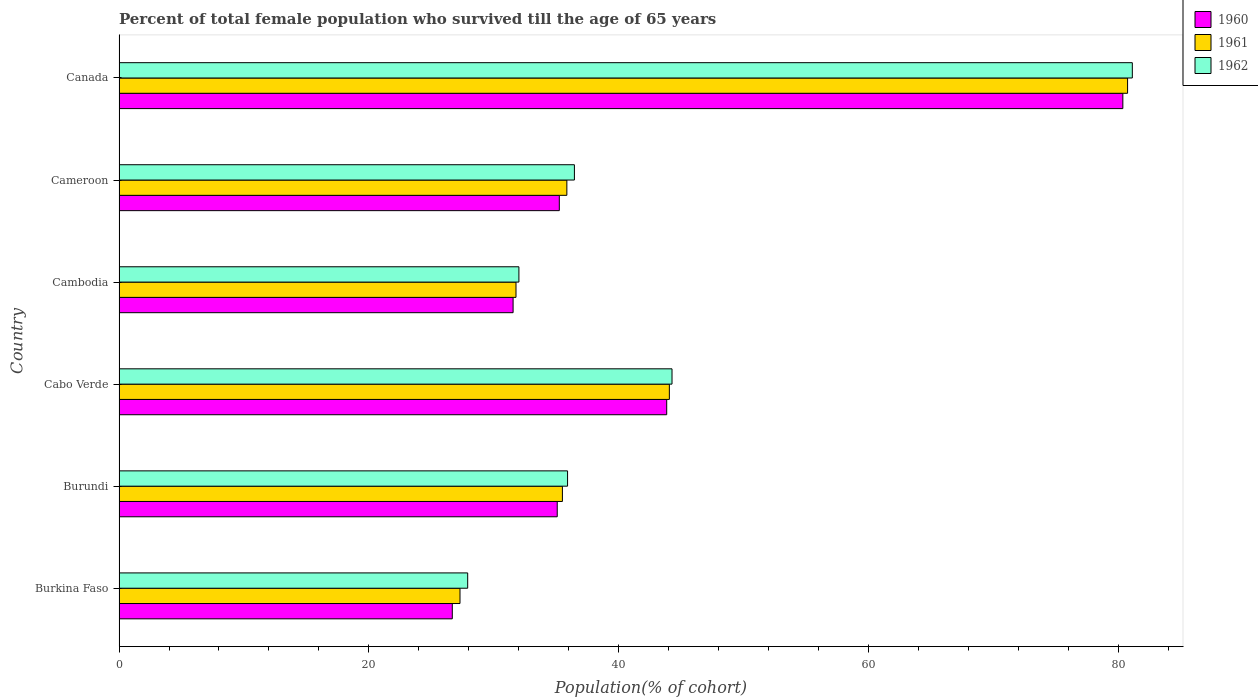How many different coloured bars are there?
Ensure brevity in your answer.  3. How many groups of bars are there?
Your answer should be very brief. 6. Are the number of bars on each tick of the Y-axis equal?
Provide a succinct answer. Yes. What is the label of the 4th group of bars from the top?
Ensure brevity in your answer.  Cabo Verde. What is the percentage of total female population who survived till the age of 65 years in 1960 in Canada?
Give a very brief answer. 80.38. Across all countries, what is the maximum percentage of total female population who survived till the age of 65 years in 1960?
Offer a very short reply. 80.38. Across all countries, what is the minimum percentage of total female population who survived till the age of 65 years in 1961?
Keep it short and to the point. 27.3. In which country was the percentage of total female population who survived till the age of 65 years in 1960 minimum?
Provide a succinct answer. Burkina Faso. What is the total percentage of total female population who survived till the age of 65 years in 1960 in the graph?
Your answer should be compact. 252.8. What is the difference between the percentage of total female population who survived till the age of 65 years in 1962 in Burkina Faso and that in Burundi?
Offer a terse response. -8. What is the difference between the percentage of total female population who survived till the age of 65 years in 1960 in Burkina Faso and the percentage of total female population who survived till the age of 65 years in 1961 in Canada?
Your answer should be very brief. -54.07. What is the average percentage of total female population who survived till the age of 65 years in 1960 per country?
Your answer should be very brief. 42.13. What is the difference between the percentage of total female population who survived till the age of 65 years in 1960 and percentage of total female population who survived till the age of 65 years in 1962 in Burkina Faso?
Provide a short and direct response. -1.23. In how many countries, is the percentage of total female population who survived till the age of 65 years in 1962 greater than 40 %?
Your answer should be compact. 2. What is the ratio of the percentage of total female population who survived till the age of 65 years in 1960 in Burundi to that in Cambodia?
Offer a very short reply. 1.11. What is the difference between the highest and the second highest percentage of total female population who survived till the age of 65 years in 1961?
Provide a succinct answer. 36.69. What is the difference between the highest and the lowest percentage of total female population who survived till the age of 65 years in 1961?
Offer a very short reply. 53.46. In how many countries, is the percentage of total female population who survived till the age of 65 years in 1961 greater than the average percentage of total female population who survived till the age of 65 years in 1961 taken over all countries?
Ensure brevity in your answer.  2. What does the 2nd bar from the top in Cambodia represents?
Provide a succinct answer. 1961. How many bars are there?
Your answer should be compact. 18. What is the difference between two consecutive major ticks on the X-axis?
Your answer should be very brief. 20. Are the values on the major ticks of X-axis written in scientific E-notation?
Keep it short and to the point. No. Does the graph contain any zero values?
Make the answer very short. No. Does the graph contain grids?
Your response must be concise. No. Where does the legend appear in the graph?
Your answer should be very brief. Top right. How many legend labels are there?
Give a very brief answer. 3. How are the legend labels stacked?
Your answer should be very brief. Vertical. What is the title of the graph?
Your answer should be very brief. Percent of total female population who survived till the age of 65 years. Does "2011" appear as one of the legend labels in the graph?
Give a very brief answer. No. What is the label or title of the X-axis?
Your response must be concise. Population(% of cohort). What is the Population(% of cohort) of 1960 in Burkina Faso?
Give a very brief answer. 26.68. What is the Population(% of cohort) of 1961 in Burkina Faso?
Your answer should be very brief. 27.3. What is the Population(% of cohort) of 1962 in Burkina Faso?
Offer a terse response. 27.92. What is the Population(% of cohort) of 1960 in Burundi?
Ensure brevity in your answer.  35.09. What is the Population(% of cohort) of 1961 in Burundi?
Offer a terse response. 35.5. What is the Population(% of cohort) of 1962 in Burundi?
Give a very brief answer. 35.91. What is the Population(% of cohort) in 1960 in Cabo Verde?
Provide a succinct answer. 43.85. What is the Population(% of cohort) of 1961 in Cabo Verde?
Make the answer very short. 44.06. What is the Population(% of cohort) of 1962 in Cabo Verde?
Your answer should be very brief. 44.28. What is the Population(% of cohort) in 1960 in Cambodia?
Your response must be concise. 31.55. What is the Population(% of cohort) in 1961 in Cambodia?
Provide a succinct answer. 31.78. What is the Population(% of cohort) of 1962 in Cambodia?
Your answer should be compact. 32.02. What is the Population(% of cohort) in 1960 in Cameroon?
Provide a succinct answer. 35.25. What is the Population(% of cohort) of 1961 in Cameroon?
Provide a short and direct response. 35.86. What is the Population(% of cohort) of 1962 in Cameroon?
Ensure brevity in your answer.  36.46. What is the Population(% of cohort) in 1960 in Canada?
Give a very brief answer. 80.38. What is the Population(% of cohort) of 1961 in Canada?
Your answer should be compact. 80.76. What is the Population(% of cohort) of 1962 in Canada?
Provide a succinct answer. 81.14. Across all countries, what is the maximum Population(% of cohort) in 1960?
Your response must be concise. 80.38. Across all countries, what is the maximum Population(% of cohort) in 1961?
Ensure brevity in your answer.  80.76. Across all countries, what is the maximum Population(% of cohort) of 1962?
Provide a short and direct response. 81.14. Across all countries, what is the minimum Population(% of cohort) in 1960?
Make the answer very short. 26.68. Across all countries, what is the minimum Population(% of cohort) of 1961?
Offer a very short reply. 27.3. Across all countries, what is the minimum Population(% of cohort) of 1962?
Provide a short and direct response. 27.92. What is the total Population(% of cohort) of 1960 in the graph?
Give a very brief answer. 252.8. What is the total Population(% of cohort) of 1961 in the graph?
Make the answer very short. 255.26. What is the total Population(% of cohort) of 1962 in the graph?
Your response must be concise. 257.72. What is the difference between the Population(% of cohort) in 1960 in Burkina Faso and that in Burundi?
Offer a terse response. -8.4. What is the difference between the Population(% of cohort) of 1961 in Burkina Faso and that in Burundi?
Offer a very short reply. -8.2. What is the difference between the Population(% of cohort) of 1962 in Burkina Faso and that in Burundi?
Make the answer very short. -8. What is the difference between the Population(% of cohort) of 1960 in Burkina Faso and that in Cabo Verde?
Provide a short and direct response. -17.17. What is the difference between the Population(% of cohort) of 1961 in Burkina Faso and that in Cabo Verde?
Your answer should be very brief. -16.76. What is the difference between the Population(% of cohort) of 1962 in Burkina Faso and that in Cabo Verde?
Make the answer very short. -16.36. What is the difference between the Population(% of cohort) in 1960 in Burkina Faso and that in Cambodia?
Your answer should be very brief. -4.87. What is the difference between the Population(% of cohort) of 1961 in Burkina Faso and that in Cambodia?
Make the answer very short. -4.48. What is the difference between the Population(% of cohort) in 1962 in Burkina Faso and that in Cambodia?
Offer a terse response. -4.1. What is the difference between the Population(% of cohort) of 1960 in Burkina Faso and that in Cameroon?
Your answer should be compact. -8.57. What is the difference between the Population(% of cohort) in 1961 in Burkina Faso and that in Cameroon?
Give a very brief answer. -8.56. What is the difference between the Population(% of cohort) in 1962 in Burkina Faso and that in Cameroon?
Your answer should be compact. -8.55. What is the difference between the Population(% of cohort) in 1960 in Burkina Faso and that in Canada?
Keep it short and to the point. -53.69. What is the difference between the Population(% of cohort) of 1961 in Burkina Faso and that in Canada?
Your response must be concise. -53.46. What is the difference between the Population(% of cohort) in 1962 in Burkina Faso and that in Canada?
Provide a short and direct response. -53.22. What is the difference between the Population(% of cohort) in 1960 in Burundi and that in Cabo Verde?
Your response must be concise. -8.76. What is the difference between the Population(% of cohort) in 1961 in Burundi and that in Cabo Verde?
Offer a very short reply. -8.56. What is the difference between the Population(% of cohort) of 1962 in Burundi and that in Cabo Verde?
Your response must be concise. -8.36. What is the difference between the Population(% of cohort) of 1960 in Burundi and that in Cambodia?
Your answer should be very brief. 3.54. What is the difference between the Population(% of cohort) of 1961 in Burundi and that in Cambodia?
Your response must be concise. 3.72. What is the difference between the Population(% of cohort) of 1962 in Burundi and that in Cambodia?
Offer a terse response. 3.9. What is the difference between the Population(% of cohort) of 1960 in Burundi and that in Cameroon?
Your answer should be compact. -0.17. What is the difference between the Population(% of cohort) in 1961 in Burundi and that in Cameroon?
Your answer should be very brief. -0.36. What is the difference between the Population(% of cohort) in 1962 in Burundi and that in Cameroon?
Ensure brevity in your answer.  -0.55. What is the difference between the Population(% of cohort) in 1960 in Burundi and that in Canada?
Offer a very short reply. -45.29. What is the difference between the Population(% of cohort) in 1961 in Burundi and that in Canada?
Your answer should be compact. -45.26. What is the difference between the Population(% of cohort) of 1962 in Burundi and that in Canada?
Your answer should be compact. -45.22. What is the difference between the Population(% of cohort) in 1960 in Cabo Verde and that in Cambodia?
Provide a short and direct response. 12.3. What is the difference between the Population(% of cohort) in 1961 in Cabo Verde and that in Cambodia?
Make the answer very short. 12.28. What is the difference between the Population(% of cohort) in 1962 in Cabo Verde and that in Cambodia?
Your response must be concise. 12.26. What is the difference between the Population(% of cohort) of 1960 in Cabo Verde and that in Cameroon?
Provide a succinct answer. 8.6. What is the difference between the Population(% of cohort) in 1961 in Cabo Verde and that in Cameroon?
Give a very brief answer. 8.21. What is the difference between the Population(% of cohort) of 1962 in Cabo Verde and that in Cameroon?
Your answer should be compact. 7.82. What is the difference between the Population(% of cohort) in 1960 in Cabo Verde and that in Canada?
Offer a terse response. -36.52. What is the difference between the Population(% of cohort) of 1961 in Cabo Verde and that in Canada?
Offer a very short reply. -36.69. What is the difference between the Population(% of cohort) of 1962 in Cabo Verde and that in Canada?
Provide a succinct answer. -36.86. What is the difference between the Population(% of cohort) in 1960 in Cambodia and that in Cameroon?
Provide a succinct answer. -3.7. What is the difference between the Population(% of cohort) of 1961 in Cambodia and that in Cameroon?
Provide a short and direct response. -4.07. What is the difference between the Population(% of cohort) in 1962 in Cambodia and that in Cameroon?
Offer a terse response. -4.44. What is the difference between the Population(% of cohort) of 1960 in Cambodia and that in Canada?
Your answer should be very brief. -48.82. What is the difference between the Population(% of cohort) of 1961 in Cambodia and that in Canada?
Ensure brevity in your answer.  -48.97. What is the difference between the Population(% of cohort) in 1962 in Cambodia and that in Canada?
Provide a succinct answer. -49.12. What is the difference between the Population(% of cohort) of 1960 in Cameroon and that in Canada?
Your response must be concise. -45.12. What is the difference between the Population(% of cohort) in 1961 in Cameroon and that in Canada?
Your response must be concise. -44.9. What is the difference between the Population(% of cohort) in 1962 in Cameroon and that in Canada?
Your answer should be very brief. -44.67. What is the difference between the Population(% of cohort) of 1960 in Burkina Faso and the Population(% of cohort) of 1961 in Burundi?
Your answer should be very brief. -8.82. What is the difference between the Population(% of cohort) of 1960 in Burkina Faso and the Population(% of cohort) of 1962 in Burundi?
Make the answer very short. -9.23. What is the difference between the Population(% of cohort) of 1961 in Burkina Faso and the Population(% of cohort) of 1962 in Burundi?
Your response must be concise. -8.61. What is the difference between the Population(% of cohort) of 1960 in Burkina Faso and the Population(% of cohort) of 1961 in Cabo Verde?
Ensure brevity in your answer.  -17.38. What is the difference between the Population(% of cohort) in 1960 in Burkina Faso and the Population(% of cohort) in 1962 in Cabo Verde?
Keep it short and to the point. -17.59. What is the difference between the Population(% of cohort) in 1961 in Burkina Faso and the Population(% of cohort) in 1962 in Cabo Verde?
Your answer should be very brief. -16.98. What is the difference between the Population(% of cohort) in 1960 in Burkina Faso and the Population(% of cohort) in 1961 in Cambodia?
Your response must be concise. -5.1. What is the difference between the Population(% of cohort) in 1960 in Burkina Faso and the Population(% of cohort) in 1962 in Cambodia?
Keep it short and to the point. -5.33. What is the difference between the Population(% of cohort) of 1961 in Burkina Faso and the Population(% of cohort) of 1962 in Cambodia?
Keep it short and to the point. -4.72. What is the difference between the Population(% of cohort) in 1960 in Burkina Faso and the Population(% of cohort) in 1961 in Cameroon?
Your answer should be compact. -9.17. What is the difference between the Population(% of cohort) in 1960 in Burkina Faso and the Population(% of cohort) in 1962 in Cameroon?
Keep it short and to the point. -9.78. What is the difference between the Population(% of cohort) in 1961 in Burkina Faso and the Population(% of cohort) in 1962 in Cameroon?
Your answer should be very brief. -9.16. What is the difference between the Population(% of cohort) of 1960 in Burkina Faso and the Population(% of cohort) of 1961 in Canada?
Ensure brevity in your answer.  -54.07. What is the difference between the Population(% of cohort) of 1960 in Burkina Faso and the Population(% of cohort) of 1962 in Canada?
Your response must be concise. -54.45. What is the difference between the Population(% of cohort) of 1961 in Burkina Faso and the Population(% of cohort) of 1962 in Canada?
Offer a terse response. -53.84. What is the difference between the Population(% of cohort) in 1960 in Burundi and the Population(% of cohort) in 1961 in Cabo Verde?
Give a very brief answer. -8.98. What is the difference between the Population(% of cohort) of 1960 in Burundi and the Population(% of cohort) of 1962 in Cabo Verde?
Give a very brief answer. -9.19. What is the difference between the Population(% of cohort) in 1961 in Burundi and the Population(% of cohort) in 1962 in Cabo Verde?
Offer a terse response. -8.78. What is the difference between the Population(% of cohort) of 1960 in Burundi and the Population(% of cohort) of 1961 in Cambodia?
Your response must be concise. 3.3. What is the difference between the Population(% of cohort) in 1960 in Burundi and the Population(% of cohort) in 1962 in Cambodia?
Offer a terse response. 3.07. What is the difference between the Population(% of cohort) in 1961 in Burundi and the Population(% of cohort) in 1962 in Cambodia?
Offer a terse response. 3.48. What is the difference between the Population(% of cohort) in 1960 in Burundi and the Population(% of cohort) in 1961 in Cameroon?
Your answer should be very brief. -0.77. What is the difference between the Population(% of cohort) in 1960 in Burundi and the Population(% of cohort) in 1962 in Cameroon?
Ensure brevity in your answer.  -1.37. What is the difference between the Population(% of cohort) in 1961 in Burundi and the Population(% of cohort) in 1962 in Cameroon?
Keep it short and to the point. -0.96. What is the difference between the Population(% of cohort) in 1960 in Burundi and the Population(% of cohort) in 1961 in Canada?
Provide a short and direct response. -45.67. What is the difference between the Population(% of cohort) in 1960 in Burundi and the Population(% of cohort) in 1962 in Canada?
Provide a succinct answer. -46.05. What is the difference between the Population(% of cohort) in 1961 in Burundi and the Population(% of cohort) in 1962 in Canada?
Offer a terse response. -45.64. What is the difference between the Population(% of cohort) of 1960 in Cabo Verde and the Population(% of cohort) of 1961 in Cambodia?
Offer a very short reply. 12.07. What is the difference between the Population(% of cohort) in 1960 in Cabo Verde and the Population(% of cohort) in 1962 in Cambodia?
Your answer should be very brief. 11.83. What is the difference between the Population(% of cohort) of 1961 in Cabo Verde and the Population(% of cohort) of 1962 in Cambodia?
Your answer should be compact. 12.05. What is the difference between the Population(% of cohort) in 1960 in Cabo Verde and the Population(% of cohort) in 1961 in Cameroon?
Keep it short and to the point. 7.99. What is the difference between the Population(% of cohort) of 1960 in Cabo Verde and the Population(% of cohort) of 1962 in Cameroon?
Keep it short and to the point. 7.39. What is the difference between the Population(% of cohort) of 1961 in Cabo Verde and the Population(% of cohort) of 1962 in Cameroon?
Your answer should be very brief. 7.6. What is the difference between the Population(% of cohort) of 1960 in Cabo Verde and the Population(% of cohort) of 1961 in Canada?
Offer a terse response. -36.9. What is the difference between the Population(% of cohort) of 1960 in Cabo Verde and the Population(% of cohort) of 1962 in Canada?
Ensure brevity in your answer.  -37.28. What is the difference between the Population(% of cohort) of 1961 in Cabo Verde and the Population(% of cohort) of 1962 in Canada?
Offer a terse response. -37.07. What is the difference between the Population(% of cohort) of 1960 in Cambodia and the Population(% of cohort) of 1961 in Cameroon?
Provide a succinct answer. -4.31. What is the difference between the Population(% of cohort) of 1960 in Cambodia and the Population(% of cohort) of 1962 in Cameroon?
Provide a short and direct response. -4.91. What is the difference between the Population(% of cohort) of 1961 in Cambodia and the Population(% of cohort) of 1962 in Cameroon?
Offer a very short reply. -4.68. What is the difference between the Population(% of cohort) of 1960 in Cambodia and the Population(% of cohort) of 1961 in Canada?
Your answer should be very brief. -49.2. What is the difference between the Population(% of cohort) of 1960 in Cambodia and the Population(% of cohort) of 1962 in Canada?
Keep it short and to the point. -49.58. What is the difference between the Population(% of cohort) of 1961 in Cambodia and the Population(% of cohort) of 1962 in Canada?
Make the answer very short. -49.35. What is the difference between the Population(% of cohort) in 1960 in Cameroon and the Population(% of cohort) in 1961 in Canada?
Make the answer very short. -45.5. What is the difference between the Population(% of cohort) of 1960 in Cameroon and the Population(% of cohort) of 1962 in Canada?
Offer a terse response. -45.88. What is the difference between the Population(% of cohort) of 1961 in Cameroon and the Population(% of cohort) of 1962 in Canada?
Ensure brevity in your answer.  -45.28. What is the average Population(% of cohort) in 1960 per country?
Keep it short and to the point. 42.13. What is the average Population(% of cohort) in 1961 per country?
Your answer should be compact. 42.54. What is the average Population(% of cohort) in 1962 per country?
Provide a succinct answer. 42.95. What is the difference between the Population(% of cohort) of 1960 and Population(% of cohort) of 1961 in Burkina Faso?
Offer a very short reply. -0.62. What is the difference between the Population(% of cohort) of 1960 and Population(% of cohort) of 1962 in Burkina Faso?
Offer a terse response. -1.23. What is the difference between the Population(% of cohort) in 1961 and Population(% of cohort) in 1962 in Burkina Faso?
Your answer should be compact. -0.62. What is the difference between the Population(% of cohort) in 1960 and Population(% of cohort) in 1961 in Burundi?
Your answer should be compact. -0.41. What is the difference between the Population(% of cohort) of 1960 and Population(% of cohort) of 1962 in Burundi?
Your response must be concise. -0.83. What is the difference between the Population(% of cohort) of 1961 and Population(% of cohort) of 1962 in Burundi?
Provide a short and direct response. -0.41. What is the difference between the Population(% of cohort) in 1960 and Population(% of cohort) in 1961 in Cabo Verde?
Offer a terse response. -0.21. What is the difference between the Population(% of cohort) of 1960 and Population(% of cohort) of 1962 in Cabo Verde?
Offer a terse response. -0.43. What is the difference between the Population(% of cohort) of 1961 and Population(% of cohort) of 1962 in Cabo Verde?
Give a very brief answer. -0.21. What is the difference between the Population(% of cohort) of 1960 and Population(% of cohort) of 1961 in Cambodia?
Give a very brief answer. -0.23. What is the difference between the Population(% of cohort) in 1960 and Population(% of cohort) in 1962 in Cambodia?
Keep it short and to the point. -0.47. What is the difference between the Population(% of cohort) in 1961 and Population(% of cohort) in 1962 in Cambodia?
Ensure brevity in your answer.  -0.23. What is the difference between the Population(% of cohort) of 1960 and Population(% of cohort) of 1961 in Cameroon?
Give a very brief answer. -0.6. What is the difference between the Population(% of cohort) of 1960 and Population(% of cohort) of 1962 in Cameroon?
Your response must be concise. -1.21. What is the difference between the Population(% of cohort) of 1961 and Population(% of cohort) of 1962 in Cameroon?
Your response must be concise. -0.6. What is the difference between the Population(% of cohort) in 1960 and Population(% of cohort) in 1961 in Canada?
Keep it short and to the point. -0.38. What is the difference between the Population(% of cohort) in 1960 and Population(% of cohort) in 1962 in Canada?
Provide a succinct answer. -0.76. What is the difference between the Population(% of cohort) of 1961 and Population(% of cohort) of 1962 in Canada?
Your answer should be very brief. -0.38. What is the ratio of the Population(% of cohort) in 1960 in Burkina Faso to that in Burundi?
Offer a very short reply. 0.76. What is the ratio of the Population(% of cohort) of 1961 in Burkina Faso to that in Burundi?
Make the answer very short. 0.77. What is the ratio of the Population(% of cohort) of 1962 in Burkina Faso to that in Burundi?
Offer a terse response. 0.78. What is the ratio of the Population(% of cohort) of 1960 in Burkina Faso to that in Cabo Verde?
Provide a short and direct response. 0.61. What is the ratio of the Population(% of cohort) in 1961 in Burkina Faso to that in Cabo Verde?
Make the answer very short. 0.62. What is the ratio of the Population(% of cohort) in 1962 in Burkina Faso to that in Cabo Verde?
Your answer should be very brief. 0.63. What is the ratio of the Population(% of cohort) in 1960 in Burkina Faso to that in Cambodia?
Keep it short and to the point. 0.85. What is the ratio of the Population(% of cohort) of 1961 in Burkina Faso to that in Cambodia?
Keep it short and to the point. 0.86. What is the ratio of the Population(% of cohort) in 1962 in Burkina Faso to that in Cambodia?
Ensure brevity in your answer.  0.87. What is the ratio of the Population(% of cohort) of 1960 in Burkina Faso to that in Cameroon?
Offer a terse response. 0.76. What is the ratio of the Population(% of cohort) of 1961 in Burkina Faso to that in Cameroon?
Your answer should be compact. 0.76. What is the ratio of the Population(% of cohort) in 1962 in Burkina Faso to that in Cameroon?
Give a very brief answer. 0.77. What is the ratio of the Population(% of cohort) in 1960 in Burkina Faso to that in Canada?
Offer a terse response. 0.33. What is the ratio of the Population(% of cohort) in 1961 in Burkina Faso to that in Canada?
Offer a very short reply. 0.34. What is the ratio of the Population(% of cohort) of 1962 in Burkina Faso to that in Canada?
Your answer should be compact. 0.34. What is the ratio of the Population(% of cohort) in 1960 in Burundi to that in Cabo Verde?
Ensure brevity in your answer.  0.8. What is the ratio of the Population(% of cohort) in 1961 in Burundi to that in Cabo Verde?
Give a very brief answer. 0.81. What is the ratio of the Population(% of cohort) in 1962 in Burundi to that in Cabo Verde?
Make the answer very short. 0.81. What is the ratio of the Population(% of cohort) of 1960 in Burundi to that in Cambodia?
Provide a succinct answer. 1.11. What is the ratio of the Population(% of cohort) in 1961 in Burundi to that in Cambodia?
Make the answer very short. 1.12. What is the ratio of the Population(% of cohort) of 1962 in Burundi to that in Cambodia?
Offer a very short reply. 1.12. What is the ratio of the Population(% of cohort) in 1961 in Burundi to that in Cameroon?
Your response must be concise. 0.99. What is the ratio of the Population(% of cohort) in 1962 in Burundi to that in Cameroon?
Offer a terse response. 0.98. What is the ratio of the Population(% of cohort) in 1960 in Burundi to that in Canada?
Your answer should be compact. 0.44. What is the ratio of the Population(% of cohort) in 1961 in Burundi to that in Canada?
Ensure brevity in your answer.  0.44. What is the ratio of the Population(% of cohort) of 1962 in Burundi to that in Canada?
Provide a short and direct response. 0.44. What is the ratio of the Population(% of cohort) of 1960 in Cabo Verde to that in Cambodia?
Ensure brevity in your answer.  1.39. What is the ratio of the Population(% of cohort) of 1961 in Cabo Verde to that in Cambodia?
Make the answer very short. 1.39. What is the ratio of the Population(% of cohort) in 1962 in Cabo Verde to that in Cambodia?
Give a very brief answer. 1.38. What is the ratio of the Population(% of cohort) in 1960 in Cabo Verde to that in Cameroon?
Provide a short and direct response. 1.24. What is the ratio of the Population(% of cohort) of 1961 in Cabo Verde to that in Cameroon?
Your answer should be very brief. 1.23. What is the ratio of the Population(% of cohort) in 1962 in Cabo Verde to that in Cameroon?
Keep it short and to the point. 1.21. What is the ratio of the Population(% of cohort) of 1960 in Cabo Verde to that in Canada?
Keep it short and to the point. 0.55. What is the ratio of the Population(% of cohort) of 1961 in Cabo Verde to that in Canada?
Provide a succinct answer. 0.55. What is the ratio of the Population(% of cohort) of 1962 in Cabo Verde to that in Canada?
Give a very brief answer. 0.55. What is the ratio of the Population(% of cohort) in 1960 in Cambodia to that in Cameroon?
Keep it short and to the point. 0.9. What is the ratio of the Population(% of cohort) in 1961 in Cambodia to that in Cameroon?
Provide a short and direct response. 0.89. What is the ratio of the Population(% of cohort) of 1962 in Cambodia to that in Cameroon?
Offer a very short reply. 0.88. What is the ratio of the Population(% of cohort) of 1960 in Cambodia to that in Canada?
Offer a terse response. 0.39. What is the ratio of the Population(% of cohort) in 1961 in Cambodia to that in Canada?
Ensure brevity in your answer.  0.39. What is the ratio of the Population(% of cohort) of 1962 in Cambodia to that in Canada?
Your answer should be very brief. 0.39. What is the ratio of the Population(% of cohort) in 1960 in Cameroon to that in Canada?
Provide a succinct answer. 0.44. What is the ratio of the Population(% of cohort) of 1961 in Cameroon to that in Canada?
Offer a very short reply. 0.44. What is the ratio of the Population(% of cohort) of 1962 in Cameroon to that in Canada?
Provide a short and direct response. 0.45. What is the difference between the highest and the second highest Population(% of cohort) in 1960?
Offer a terse response. 36.52. What is the difference between the highest and the second highest Population(% of cohort) in 1961?
Make the answer very short. 36.69. What is the difference between the highest and the second highest Population(% of cohort) in 1962?
Make the answer very short. 36.86. What is the difference between the highest and the lowest Population(% of cohort) in 1960?
Ensure brevity in your answer.  53.69. What is the difference between the highest and the lowest Population(% of cohort) of 1961?
Make the answer very short. 53.46. What is the difference between the highest and the lowest Population(% of cohort) in 1962?
Provide a short and direct response. 53.22. 